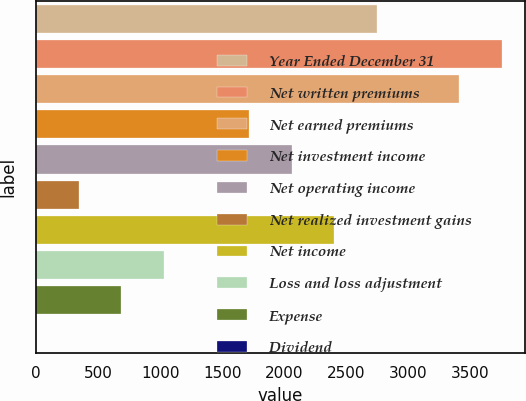Convert chart to OTSL. <chart><loc_0><loc_0><loc_500><loc_500><bar_chart><fcel>Year Ended December 31<fcel>Net written premiums<fcel>Net earned premiums<fcel>Net investment income<fcel>Net operating income<fcel>Net realized investment gains<fcel>Net income<fcel>Loss and loss adjustment<fcel>Expense<fcel>Dividend<nl><fcel>2744.82<fcel>3754.09<fcel>3411<fcel>1715.55<fcel>2058.64<fcel>343.19<fcel>2401.73<fcel>1029.37<fcel>686.28<fcel>0.1<nl></chart> 